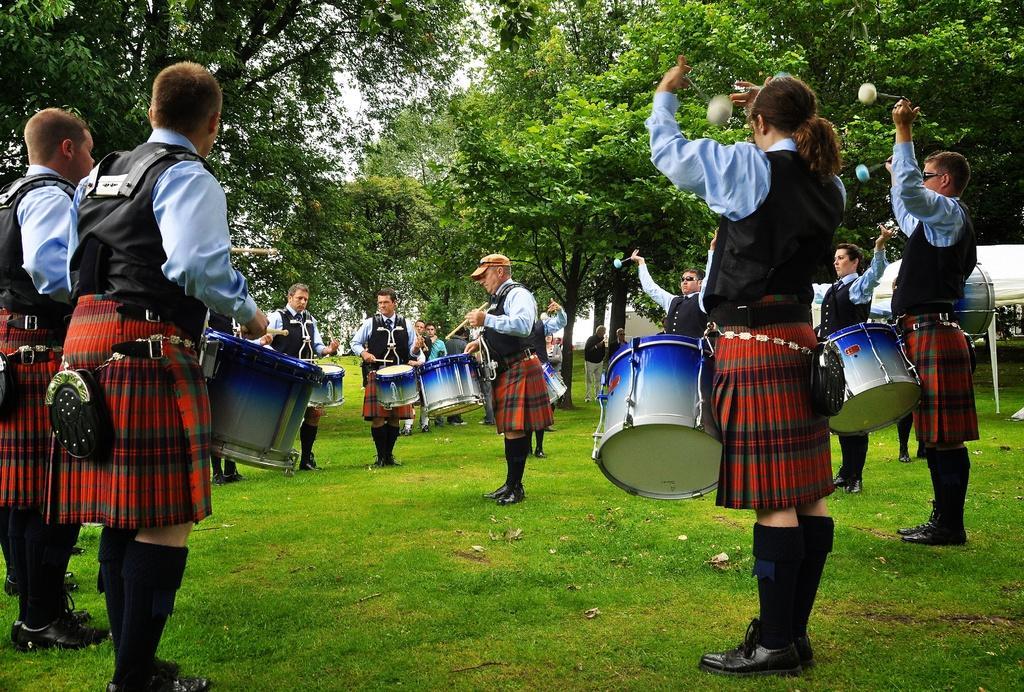Can you describe this image briefly? In the image we can see there are people standing on the ground and holding drum and sticks in their hand. The ground is covered with grass and behind there are lot of trees. 